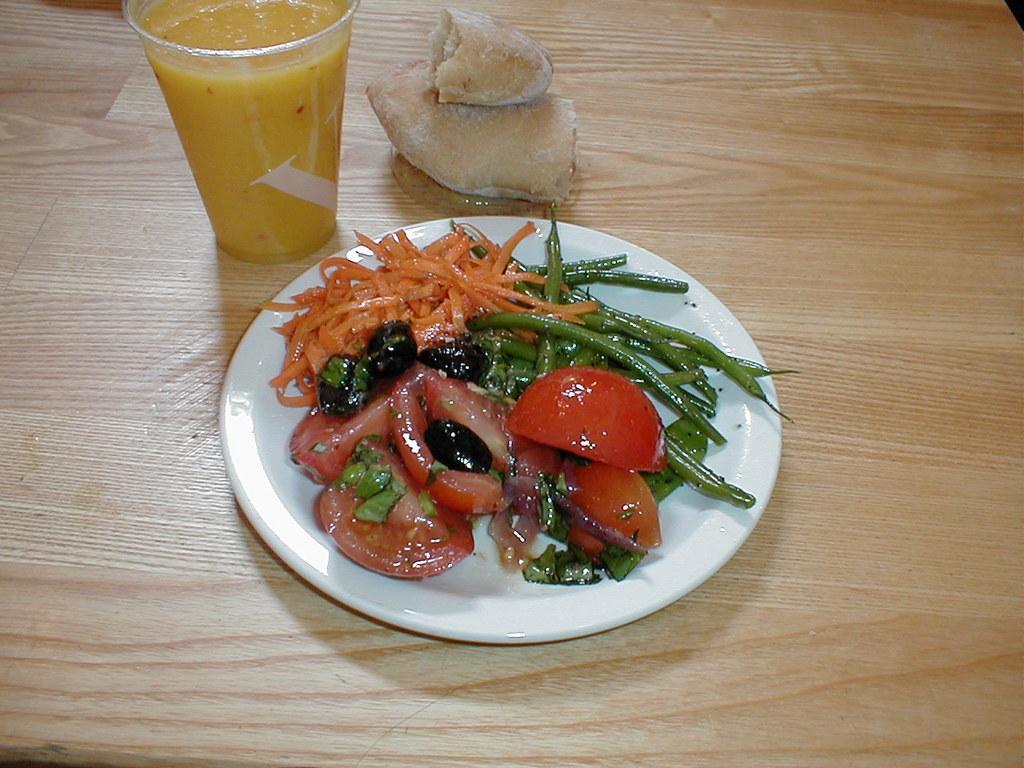In one or two sentences, can you explain what this image depicts? In this image, we can see few items are placed on a wooden surface. Here there is a plate some food item is placed on it. Top of the image, we can see a glass with juice. 